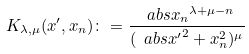<formula> <loc_0><loc_0><loc_500><loc_500>K _ { \lambda , \mu } ( x ^ { \prime } , x _ { n } ) \colon = \frac { \ a b s { x _ { n } } ^ { \lambda + \mu - n } } { ( \ a b s { x ^ { \prime } } ^ { 2 } + x _ { n } ^ { 2 } ) ^ { \mu } }</formula> 